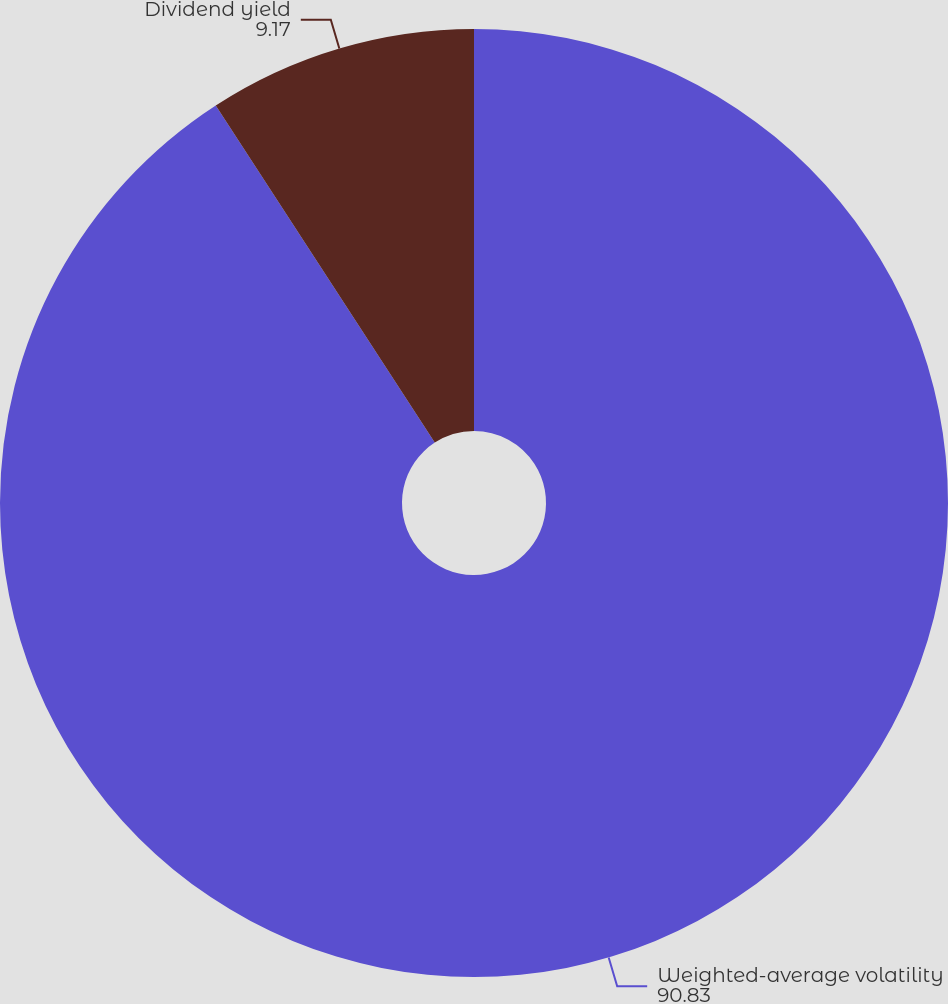<chart> <loc_0><loc_0><loc_500><loc_500><pie_chart><fcel>Weighted-average volatility<fcel>Dividend yield<nl><fcel>90.83%<fcel>9.17%<nl></chart> 